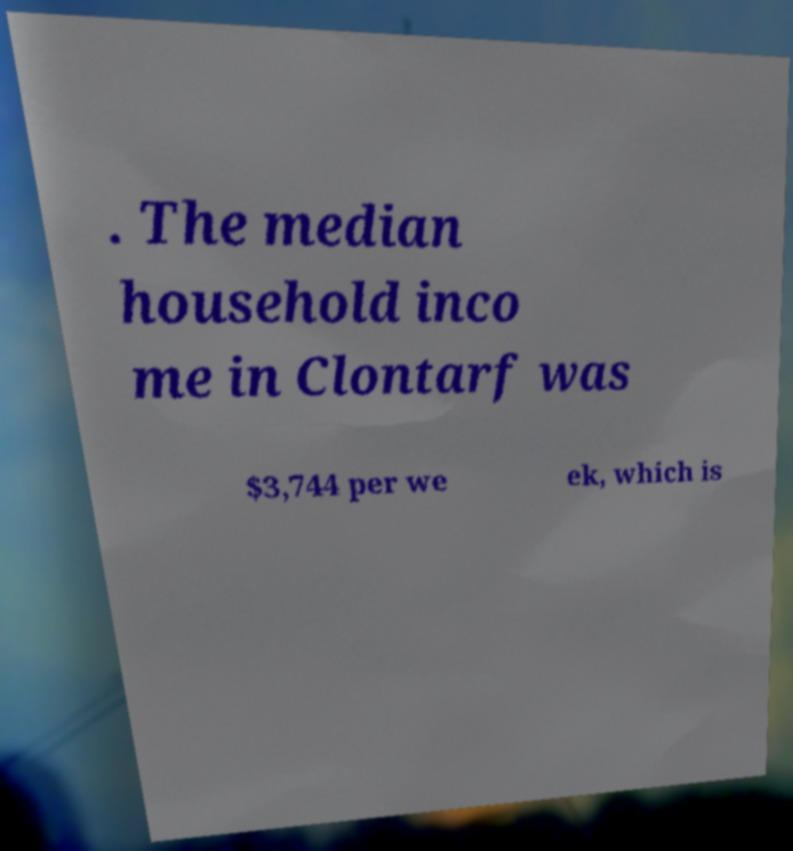Can you accurately transcribe the text from the provided image for me? . The median household inco me in Clontarf was $3,744 per we ek, which is 